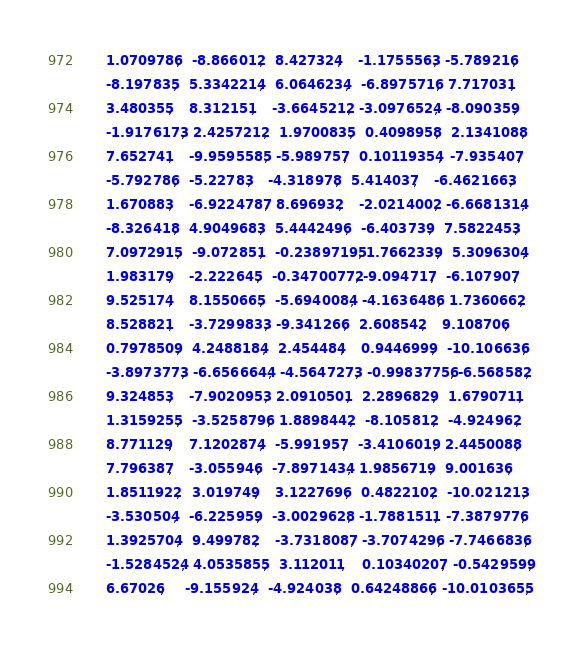<code> <loc_0><loc_0><loc_500><loc_500><_Cuda_>      1.0709786,   -8.866012,   8.427324,    -1.1755563,  -5.789216,
      -8.197835,   5.3342214,   6.0646234,   -6.8975716,  7.717031,
      3.480355,    8.312151,    -3.6645212,  -3.0976524,  -8.090359,
      -1.9176173,  2.4257212,   1.9700835,   0.4098958,   2.1341088,
      7.652741,    -9.9595585,  -5.989757,   0.10119354,  -7.935407,
      -5.792786,   -5.22783,    -4.318978,   5.414037,    -6.4621663,
      1.670883,    -6.9224787,  8.696932,    -2.0214002,  -6.6681314,
      -8.326418,   4.9049683,   5.4442496,   -6.403739,   7.5822453,
      7.0972915,   -9.072851,   -0.23897195, 1.7662339,   5.3096304,
      1.983179,    -2.222645,   -0.34700772, -9.094717,   -6.107907,
      9.525174,    8.1550665,   -5.6940084,  -4.1636486,  1.7360662,
      8.528821,    -3.7299833,  -9.341266,   2.608542,    9.108706,
      0.7978509,   4.2488184,   2.454484,    0.9446999,   -10.106636,
      -3.8973773,  -6.6566644,  -4.5647273,  -0.99837756, -6.568582,
      9.324853,    -7.9020953,  2.0910501,   2.2896829,   1.6790711,
      1.3159255,   -3.5258796,  1.8898442,   -8.105812,   -4.924962,
      8.771129,    7.1202874,   -5.991957,   -3.4106019,  2.4450088,
      7.796387,    -3.055946,   -7.8971434,  1.9856719,   9.001636,
      1.8511922,   3.019749,    3.1227696,   0.4822102,   -10.021213,
      -3.530504,   -6.225959,   -3.0029628,  -1.7881511,  -7.3879776,
      1.3925704,   9.499782,    -3.7318087,  -3.7074296,  -7.7466836,
      -1.5284524,  4.0535855,   3.112011,    0.10340207,  -0.5429599,
      6.67026,     -9.155924,   -4.924038,   0.64248866,  -10.0103655,</code> 